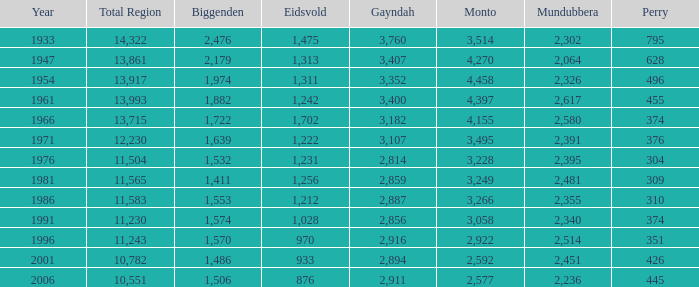What is the total area number of the one that has eidsvold at 970 and biggenden greater than 1,570? 0.0. Could you parse the entire table? {'header': ['Year', 'Total Region', 'Biggenden', 'Eidsvold', 'Gayndah', 'Monto', 'Mundubbera', 'Perry'], 'rows': [['1933', '14,322', '2,476', '1,475', '3,760', '3,514', '2,302', '795'], ['1947', '13,861', '2,179', '1,313', '3,407', '4,270', '2,064', '628'], ['1954', '13,917', '1,974', '1,311', '3,352', '4,458', '2,326', '496'], ['1961', '13,993', '1,882', '1,242', '3,400', '4,397', '2,617', '455'], ['1966', '13,715', '1,722', '1,702', '3,182', '4,155', '2,580', '374'], ['1971', '12,230', '1,639', '1,222', '3,107', '3,495', '2,391', '376'], ['1976', '11,504', '1,532', '1,231', '2,814', '3,228', '2,395', '304'], ['1981', '11,565', '1,411', '1,256', '2,859', '3,249', '2,481', '309'], ['1986', '11,583', '1,553', '1,212', '2,887', '3,266', '2,355', '310'], ['1991', '11,230', '1,574', '1,028', '2,856', '3,058', '2,340', '374'], ['1996', '11,243', '1,570', '970', '2,916', '2,922', '2,514', '351'], ['2001', '10,782', '1,486', '933', '2,894', '2,592', '2,451', '426'], ['2006', '10,551', '1,506', '876', '2,911', '2,577', '2,236', '445']]} 